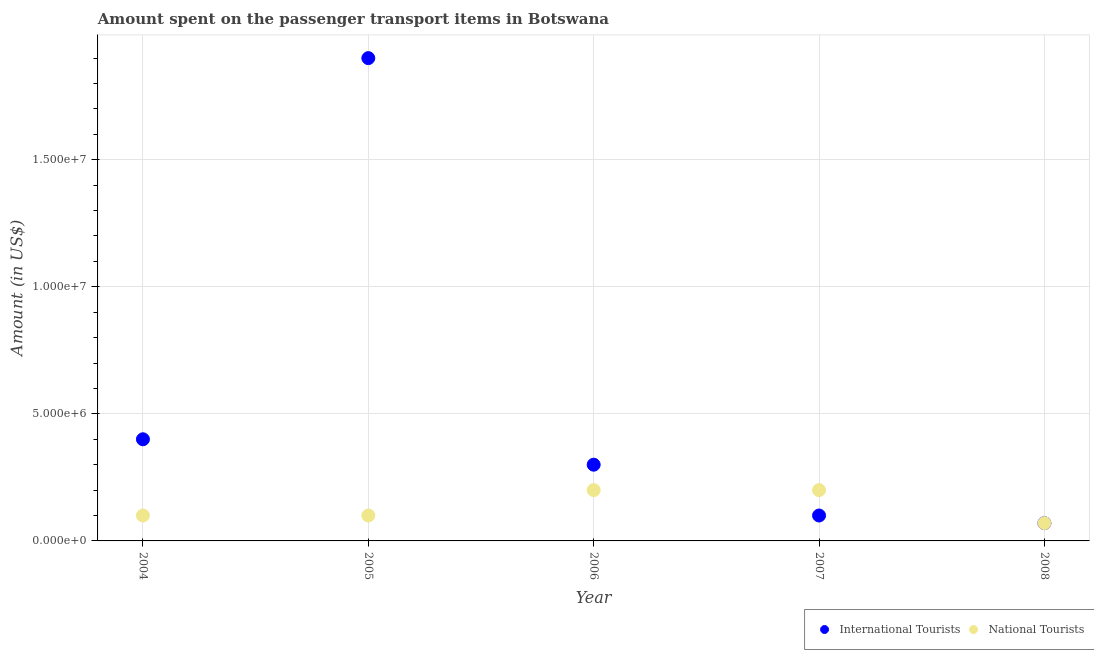What is the amount spent on transport items of international tourists in 2008?
Ensure brevity in your answer.  7.00e+05. Across all years, what is the maximum amount spent on transport items of national tourists?
Ensure brevity in your answer.  2.00e+06. Across all years, what is the minimum amount spent on transport items of national tourists?
Your answer should be very brief. 7.00e+05. In which year was the amount spent on transport items of international tourists minimum?
Offer a terse response. 2008. What is the total amount spent on transport items of national tourists in the graph?
Offer a very short reply. 6.70e+06. What is the difference between the amount spent on transport items of national tourists in 2004 and that in 2006?
Make the answer very short. -1.00e+06. What is the difference between the amount spent on transport items of national tourists in 2007 and the amount spent on transport items of international tourists in 2004?
Provide a short and direct response. -2.00e+06. What is the average amount spent on transport items of international tourists per year?
Offer a very short reply. 5.54e+06. In the year 2005, what is the difference between the amount spent on transport items of national tourists and amount spent on transport items of international tourists?
Provide a short and direct response. -1.80e+07. What is the ratio of the amount spent on transport items of national tourists in 2006 to that in 2008?
Offer a terse response. 2.86. Is the amount spent on transport items of national tourists in 2004 less than that in 2005?
Provide a short and direct response. No. Is the difference between the amount spent on transport items of international tourists in 2004 and 2008 greater than the difference between the amount spent on transport items of national tourists in 2004 and 2008?
Offer a terse response. Yes. What is the difference between the highest and the lowest amount spent on transport items of international tourists?
Your answer should be compact. 1.83e+07. In how many years, is the amount spent on transport items of national tourists greater than the average amount spent on transport items of national tourists taken over all years?
Make the answer very short. 2. How many dotlines are there?
Make the answer very short. 2. Where does the legend appear in the graph?
Offer a very short reply. Bottom right. How many legend labels are there?
Offer a very short reply. 2. How are the legend labels stacked?
Provide a succinct answer. Horizontal. What is the title of the graph?
Provide a short and direct response. Amount spent on the passenger transport items in Botswana. Does "Nitrous oxide emissions" appear as one of the legend labels in the graph?
Provide a succinct answer. No. What is the label or title of the X-axis?
Offer a terse response. Year. What is the Amount (in US$) in International Tourists in 2004?
Ensure brevity in your answer.  4.00e+06. What is the Amount (in US$) in National Tourists in 2004?
Your answer should be compact. 1.00e+06. What is the Amount (in US$) in International Tourists in 2005?
Offer a terse response. 1.90e+07. What is the Amount (in US$) in National Tourists in 2005?
Ensure brevity in your answer.  1.00e+06. What is the Amount (in US$) in National Tourists in 2007?
Keep it short and to the point. 2.00e+06. What is the Amount (in US$) in National Tourists in 2008?
Your response must be concise. 7.00e+05. Across all years, what is the maximum Amount (in US$) in International Tourists?
Provide a short and direct response. 1.90e+07. Across all years, what is the minimum Amount (in US$) in International Tourists?
Offer a very short reply. 7.00e+05. What is the total Amount (in US$) of International Tourists in the graph?
Your response must be concise. 2.77e+07. What is the total Amount (in US$) in National Tourists in the graph?
Provide a short and direct response. 6.70e+06. What is the difference between the Amount (in US$) of International Tourists in 2004 and that in 2005?
Give a very brief answer. -1.50e+07. What is the difference between the Amount (in US$) of National Tourists in 2004 and that in 2005?
Your answer should be compact. 0. What is the difference between the Amount (in US$) in International Tourists in 2004 and that in 2006?
Make the answer very short. 1.00e+06. What is the difference between the Amount (in US$) of National Tourists in 2004 and that in 2006?
Offer a very short reply. -1.00e+06. What is the difference between the Amount (in US$) in International Tourists in 2004 and that in 2007?
Provide a succinct answer. 3.00e+06. What is the difference between the Amount (in US$) in International Tourists in 2004 and that in 2008?
Your answer should be very brief. 3.30e+06. What is the difference between the Amount (in US$) in National Tourists in 2004 and that in 2008?
Your answer should be very brief. 3.00e+05. What is the difference between the Amount (in US$) of International Tourists in 2005 and that in 2006?
Your answer should be compact. 1.60e+07. What is the difference between the Amount (in US$) of National Tourists in 2005 and that in 2006?
Offer a very short reply. -1.00e+06. What is the difference between the Amount (in US$) in International Tourists in 2005 and that in 2007?
Offer a very short reply. 1.80e+07. What is the difference between the Amount (in US$) in International Tourists in 2005 and that in 2008?
Ensure brevity in your answer.  1.83e+07. What is the difference between the Amount (in US$) of International Tourists in 2006 and that in 2008?
Offer a very short reply. 2.30e+06. What is the difference between the Amount (in US$) of National Tourists in 2006 and that in 2008?
Your response must be concise. 1.30e+06. What is the difference between the Amount (in US$) of International Tourists in 2007 and that in 2008?
Offer a very short reply. 3.00e+05. What is the difference between the Amount (in US$) of National Tourists in 2007 and that in 2008?
Provide a succinct answer. 1.30e+06. What is the difference between the Amount (in US$) of International Tourists in 2004 and the Amount (in US$) of National Tourists in 2008?
Give a very brief answer. 3.30e+06. What is the difference between the Amount (in US$) in International Tourists in 2005 and the Amount (in US$) in National Tourists in 2006?
Your response must be concise. 1.70e+07. What is the difference between the Amount (in US$) of International Tourists in 2005 and the Amount (in US$) of National Tourists in 2007?
Make the answer very short. 1.70e+07. What is the difference between the Amount (in US$) of International Tourists in 2005 and the Amount (in US$) of National Tourists in 2008?
Offer a very short reply. 1.83e+07. What is the difference between the Amount (in US$) of International Tourists in 2006 and the Amount (in US$) of National Tourists in 2007?
Your answer should be very brief. 1.00e+06. What is the difference between the Amount (in US$) in International Tourists in 2006 and the Amount (in US$) in National Tourists in 2008?
Provide a short and direct response. 2.30e+06. What is the difference between the Amount (in US$) in International Tourists in 2007 and the Amount (in US$) in National Tourists in 2008?
Make the answer very short. 3.00e+05. What is the average Amount (in US$) of International Tourists per year?
Provide a succinct answer. 5.54e+06. What is the average Amount (in US$) in National Tourists per year?
Ensure brevity in your answer.  1.34e+06. In the year 2004, what is the difference between the Amount (in US$) in International Tourists and Amount (in US$) in National Tourists?
Offer a very short reply. 3.00e+06. In the year 2005, what is the difference between the Amount (in US$) in International Tourists and Amount (in US$) in National Tourists?
Offer a very short reply. 1.80e+07. In the year 2007, what is the difference between the Amount (in US$) in International Tourists and Amount (in US$) in National Tourists?
Give a very brief answer. -1.00e+06. In the year 2008, what is the difference between the Amount (in US$) of International Tourists and Amount (in US$) of National Tourists?
Give a very brief answer. 0. What is the ratio of the Amount (in US$) of International Tourists in 2004 to that in 2005?
Offer a very short reply. 0.21. What is the ratio of the Amount (in US$) in National Tourists in 2004 to that in 2006?
Offer a very short reply. 0.5. What is the ratio of the Amount (in US$) of International Tourists in 2004 to that in 2008?
Offer a very short reply. 5.71. What is the ratio of the Amount (in US$) of National Tourists in 2004 to that in 2008?
Your response must be concise. 1.43. What is the ratio of the Amount (in US$) in International Tourists in 2005 to that in 2006?
Provide a succinct answer. 6.33. What is the ratio of the Amount (in US$) in National Tourists in 2005 to that in 2006?
Make the answer very short. 0.5. What is the ratio of the Amount (in US$) of International Tourists in 2005 to that in 2007?
Provide a succinct answer. 19. What is the ratio of the Amount (in US$) of National Tourists in 2005 to that in 2007?
Ensure brevity in your answer.  0.5. What is the ratio of the Amount (in US$) in International Tourists in 2005 to that in 2008?
Keep it short and to the point. 27.14. What is the ratio of the Amount (in US$) in National Tourists in 2005 to that in 2008?
Keep it short and to the point. 1.43. What is the ratio of the Amount (in US$) of International Tourists in 2006 to that in 2007?
Provide a succinct answer. 3. What is the ratio of the Amount (in US$) of National Tourists in 2006 to that in 2007?
Ensure brevity in your answer.  1. What is the ratio of the Amount (in US$) of International Tourists in 2006 to that in 2008?
Your response must be concise. 4.29. What is the ratio of the Amount (in US$) in National Tourists in 2006 to that in 2008?
Give a very brief answer. 2.86. What is the ratio of the Amount (in US$) in International Tourists in 2007 to that in 2008?
Offer a very short reply. 1.43. What is the ratio of the Amount (in US$) in National Tourists in 2007 to that in 2008?
Give a very brief answer. 2.86. What is the difference between the highest and the second highest Amount (in US$) of International Tourists?
Offer a very short reply. 1.50e+07. What is the difference between the highest and the second highest Amount (in US$) in National Tourists?
Keep it short and to the point. 0. What is the difference between the highest and the lowest Amount (in US$) in International Tourists?
Provide a succinct answer. 1.83e+07. What is the difference between the highest and the lowest Amount (in US$) in National Tourists?
Your answer should be compact. 1.30e+06. 